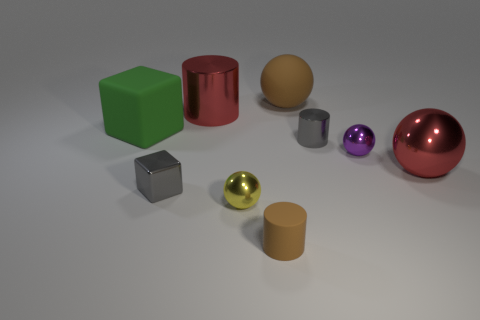Subtract all large red spheres. How many spheres are left? 3 Add 1 tiny objects. How many objects exist? 10 Subtract all cylinders. How many objects are left? 6 Add 6 tiny purple metallic spheres. How many tiny purple metallic spheres exist? 7 Subtract all brown cylinders. How many cylinders are left? 2 Subtract 0 gray spheres. How many objects are left? 9 Subtract 2 balls. How many balls are left? 2 Subtract all brown spheres. Subtract all red cubes. How many spheres are left? 3 Subtract all blue blocks. How many brown cylinders are left? 1 Subtract all tiny yellow matte blocks. Subtract all tiny blocks. How many objects are left? 8 